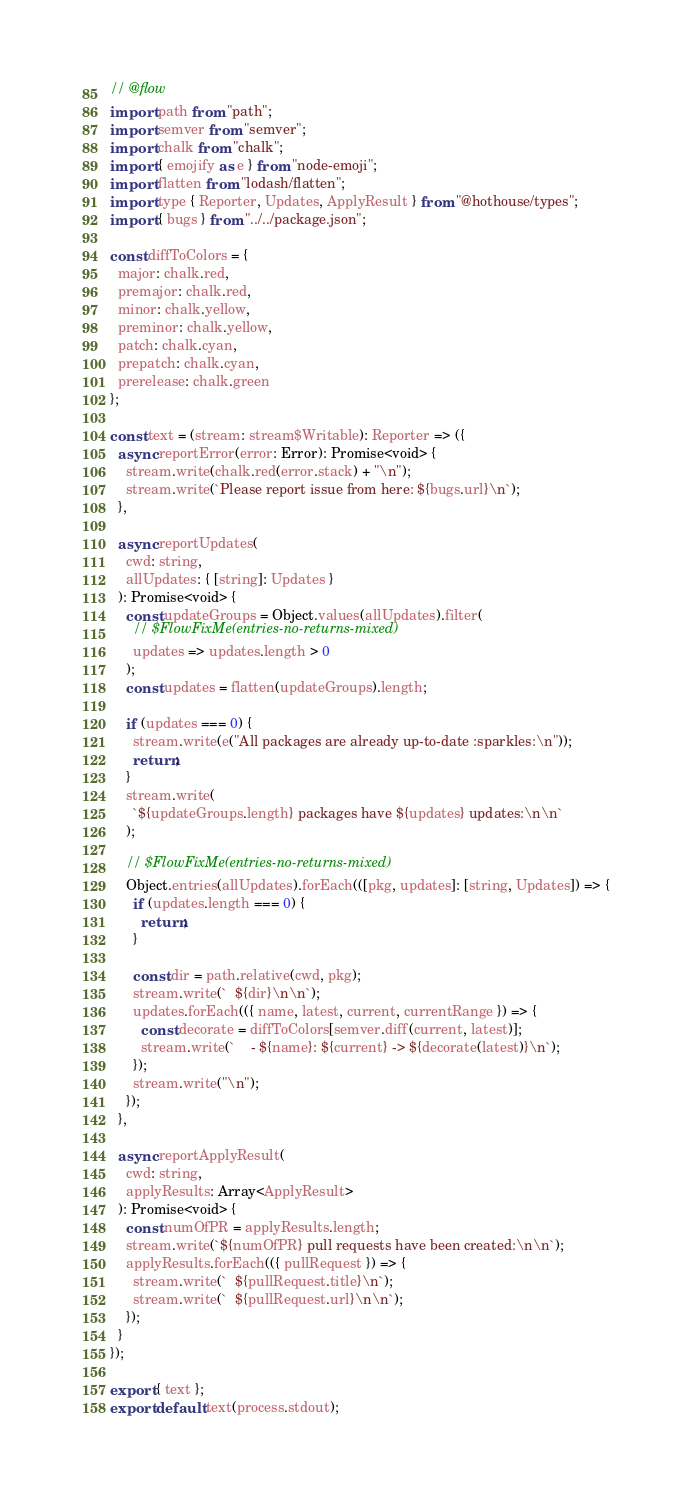Convert code to text. <code><loc_0><loc_0><loc_500><loc_500><_JavaScript_>// @flow
import path from "path";
import semver from "semver";
import chalk from "chalk";
import { emojify as e } from "node-emoji";
import flatten from "lodash/flatten";
import type { Reporter, Updates, ApplyResult } from "@hothouse/types";
import { bugs } from "../../package.json";

const diffToColors = {
  major: chalk.red,
  premajor: chalk.red,
  minor: chalk.yellow,
  preminor: chalk.yellow,
  patch: chalk.cyan,
  prepatch: chalk.cyan,
  prerelease: chalk.green
};

const text = (stream: stream$Writable): Reporter => ({
  async reportError(error: Error): Promise<void> {
    stream.write(chalk.red(error.stack) + "\n");
    stream.write(`Please report issue from here: ${bugs.url}\n`);
  },

  async reportUpdates(
    cwd: string,
    allUpdates: { [string]: Updates }
  ): Promise<void> {
    const updateGroups = Object.values(allUpdates).filter(
      // $FlowFixMe(entries-no-returns-mixed)
      updates => updates.length > 0
    );
    const updates = flatten(updateGroups).length;

    if (updates === 0) {
      stream.write(e("All packages are already up-to-date :sparkles:\n"));
      return;
    }
    stream.write(
      `${updateGroups.length} packages have ${updates} updates:\n\n`
    );

    // $FlowFixMe(entries-no-returns-mixed)
    Object.entries(allUpdates).forEach(([pkg, updates]: [string, Updates]) => {
      if (updates.length === 0) {
        return;
      }

      const dir = path.relative(cwd, pkg);
      stream.write(`  ${dir}\n\n`);
      updates.forEach(({ name, latest, current, currentRange }) => {
        const decorate = diffToColors[semver.diff(current, latest)];
        stream.write(`    - ${name}: ${current} -> ${decorate(latest)}\n`);
      });
      stream.write("\n");
    });
  },

  async reportApplyResult(
    cwd: string,
    applyResults: Array<ApplyResult>
  ): Promise<void> {
    const numOfPR = applyResults.length;
    stream.write(`${numOfPR} pull requests have been created:\n\n`);
    applyResults.forEach(({ pullRequest }) => {
      stream.write(`  ${pullRequest.title}\n`);
      stream.write(`  ${pullRequest.url}\n\n`);
    });
  }
});

export { text };
export default text(process.stdout);
</code> 